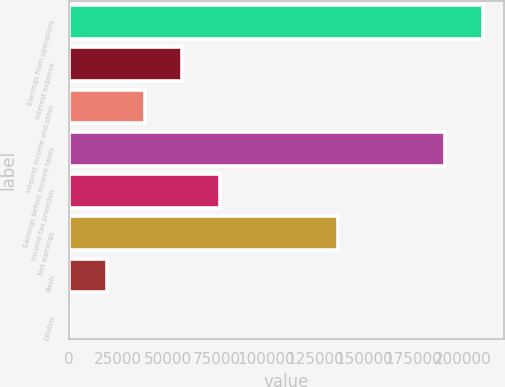Convert chart to OTSL. <chart><loc_0><loc_0><loc_500><loc_500><bar_chart><fcel>Earnings from operations<fcel>Interest expense<fcel>Interest income and other<fcel>Earnings before income taxes<fcel>Income tax provision<fcel>Net earnings<fcel>Basic<fcel>Diluted<nl><fcel>210336<fcel>57550.2<fcel>38367.1<fcel>191153<fcel>76733.3<fcel>136711<fcel>19184<fcel>0.89<nl></chart> 